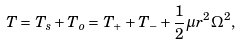<formula> <loc_0><loc_0><loc_500><loc_500>T = T _ { s } + T _ { o } = T _ { + } + T _ { - } + \frac { 1 } { 2 } \mu r ^ { 2 } \Omega ^ { 2 } ,</formula> 